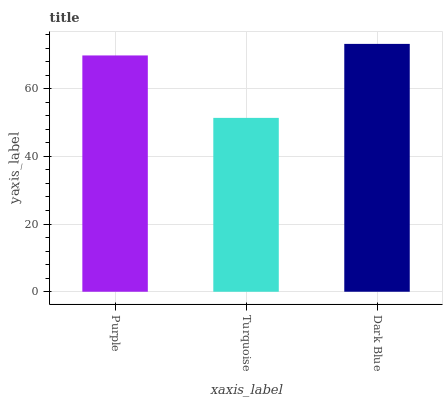Is Turquoise the minimum?
Answer yes or no. Yes. Is Dark Blue the maximum?
Answer yes or no. Yes. Is Dark Blue the minimum?
Answer yes or no. No. Is Turquoise the maximum?
Answer yes or no. No. Is Dark Blue greater than Turquoise?
Answer yes or no. Yes. Is Turquoise less than Dark Blue?
Answer yes or no. Yes. Is Turquoise greater than Dark Blue?
Answer yes or no. No. Is Dark Blue less than Turquoise?
Answer yes or no. No. Is Purple the high median?
Answer yes or no. Yes. Is Purple the low median?
Answer yes or no. Yes. Is Dark Blue the high median?
Answer yes or no. No. Is Turquoise the low median?
Answer yes or no. No. 